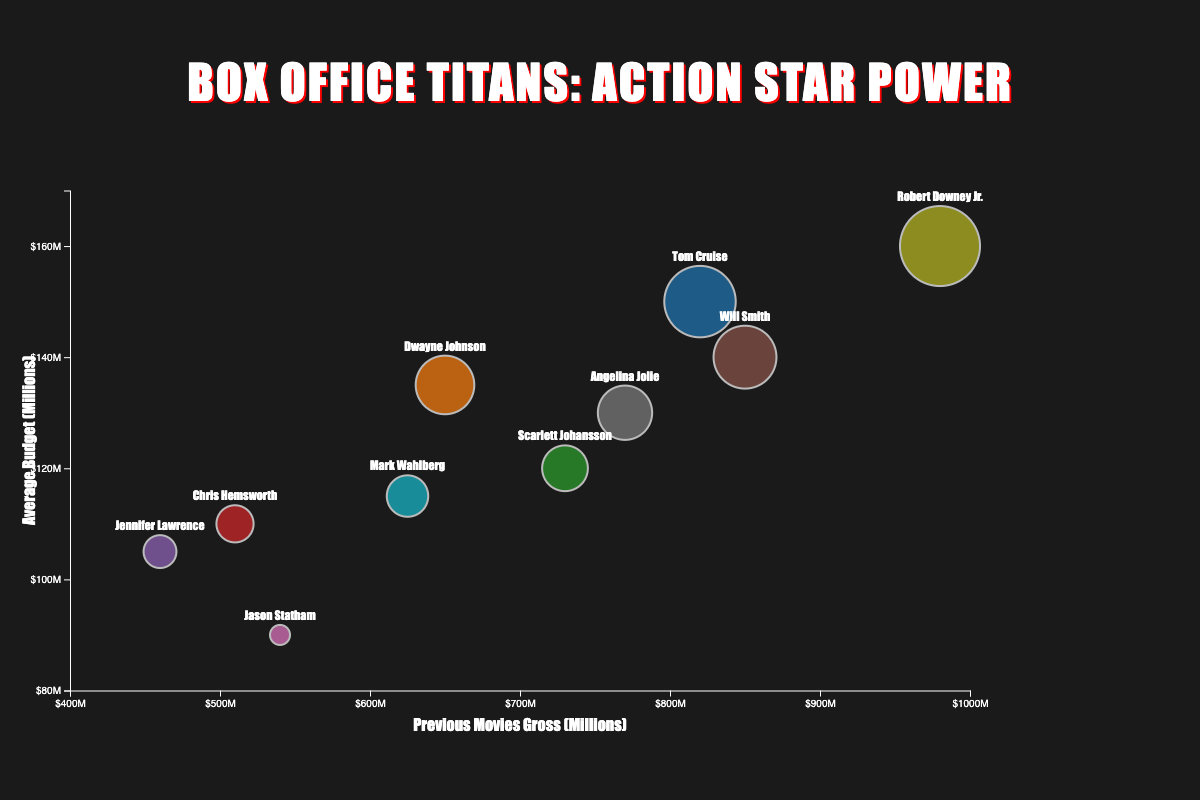What is the title of the chart? The title is located at the top-center of the chart in large letters. It reads "Box Office Titans: Action Star Power".
Answer: Box Office Titans: Action Star Power Which actor has the highest previous movie gross based on the bubble chart? Look at the x-axis, which represents previous movies gross. The furthest bubble to the right represents the actor with the highest value. Robert Downey Jr.'s bubble is the furthest to the right.
Answer: Robert Downey Jr What is the range of average budgets displayed on the y-axis? The y-axis ranges from 80 to 170 million dollars, as shown by the numerical labels and axis limits.
Answer: 80–170 million dollars Which actor has the smallest bubble in the chart, and what does it represent? The smallest bubble indicates the actor with the lowest average movie budget. Jason Statham’s bubble is the smallest.
Answer: Jason Statham Compare the previous movie gross of Tom Cruise and Will Smith. Who has the higher value? Locate the bubbles for Tom Cruise and Will Smith along the x-axis. Will Smith has a value of 850 million, higher than Tom Cruise’s value of 820 million.
Answer: Will Smith What’s the average previous movies gross of Scarlett Johansson and Mark Wahlberg combined? Add Scarlett Johansson's gross (730 million) and Mark Wahlberg's gross (625 million), then divide by 2: (730 + 625) / 2.
Answer: 677.5 million dollars Who has a higher average budget: Angelina Jolie or Dwayne Johnson? Locate the bubbles for Angelina Jolie and Dwayne Johnson along the y-axis. Angelina Jolie's average budget is 130 million, compared to Dwayne Johnson’s 135 million.
Answer: Dwayne Johnson Which actor's data point has the largest bubble size, and what does it represent? The largest bubble represents the actor with the highest average movie budget. Robert Downey Jr. has the largest bubble, indicating the highest budget.
Answer: Robert Downey Jr What is the relationship between previous movie gross and average budget observed from the chart? Generally, actors with higher previous grosses tend to have higher average budgets, as there is a positive trend from the bottom-left to top-right of the chart.
Answer: Positive Trend 